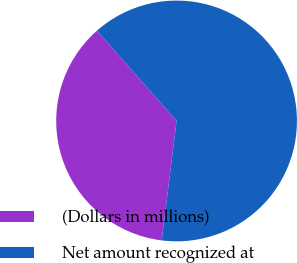Convert chart. <chart><loc_0><loc_0><loc_500><loc_500><pie_chart><fcel>(Dollars in millions)<fcel>Net amount recognized at<nl><fcel>36.53%<fcel>63.47%<nl></chart> 